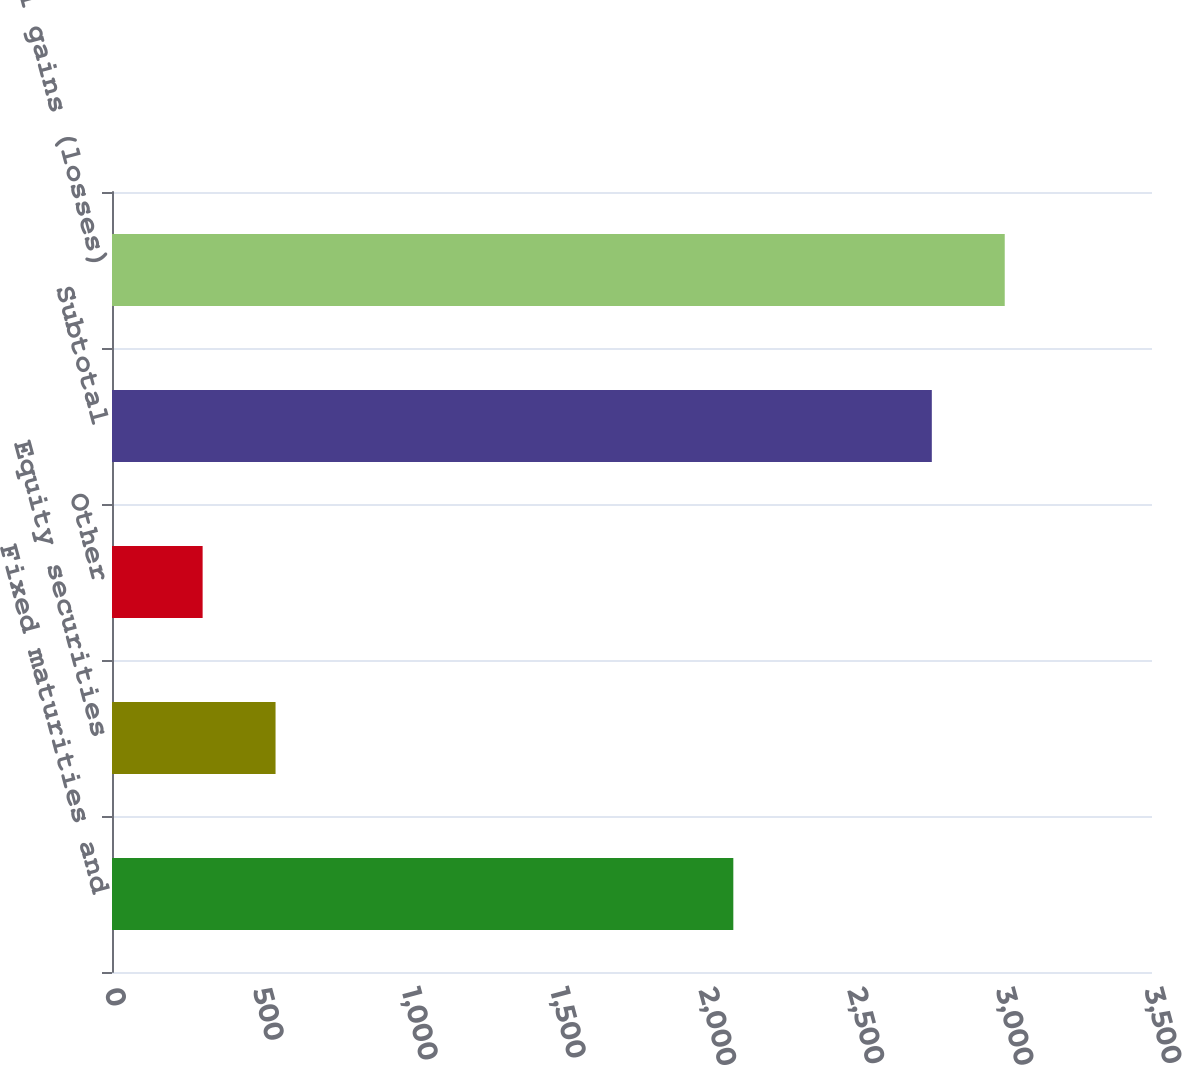Convert chart to OTSL. <chart><loc_0><loc_0><loc_500><loc_500><bar_chart><fcel>Fixed maturities and<fcel>Equity securities<fcel>Other<fcel>Subtotal<fcel>Total gains (losses)<nl><fcel>2091<fcel>550.4<fcel>305<fcel>2759<fcel>3004.4<nl></chart> 